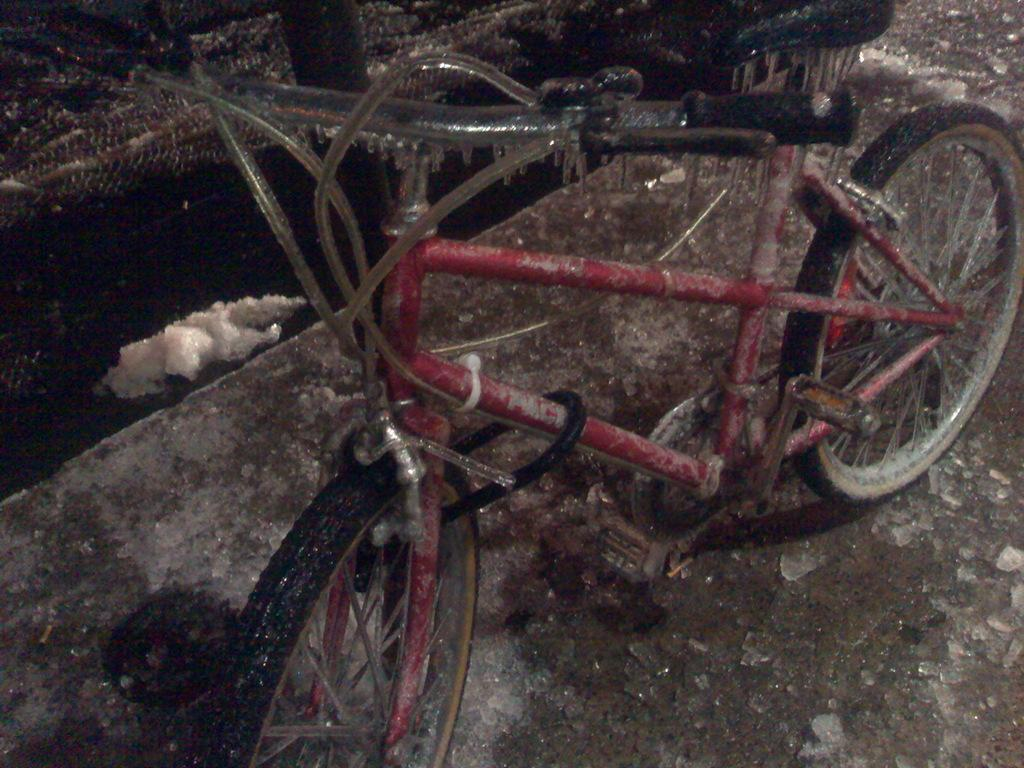What is the main subject of the image? The main subject of the image is a bicycle. Where is the bicycle located in the image? The bicycle is in the center of the image. What is the position of the bicycle in relation to the ground? The bicycle is on the ground. What shape is the bicycle in the image? The bicycle in the image is not a specific shape, but rather a combination of various shapes that make up its structure. What type of destruction can be seen happening to the bicycle in the image? There is no destruction happening to the bicycle in the image; it appears to be intact and undamaged. 